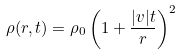<formula> <loc_0><loc_0><loc_500><loc_500>\rho ( r , t ) = \rho _ { 0 } \left ( 1 + \frac { | v | t } { r } \right ) ^ { 2 }</formula> 